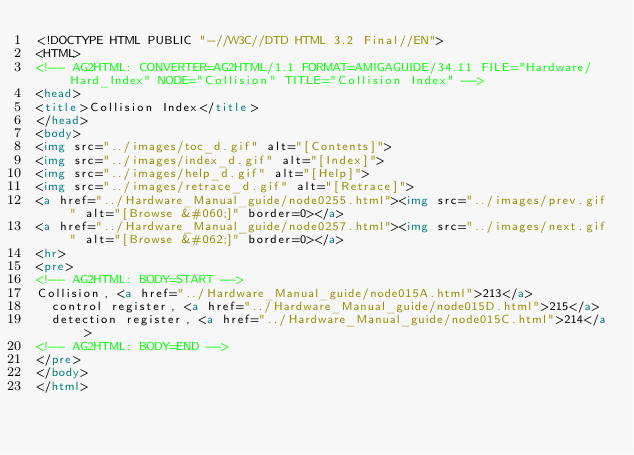<code> <loc_0><loc_0><loc_500><loc_500><_HTML_><!DOCTYPE HTML PUBLIC "-//W3C//DTD HTML 3.2 Final//EN">
<HTML>
<!-- AG2HTML: CONVERTER=AG2HTML/1.1 FORMAT=AMIGAGUIDE/34.11 FILE="Hardware/Hard_Index" NODE="Collision" TITLE="Collision Index" -->
<head>
<title>Collision Index</title>
</head>
<body>
<img src="../images/toc_d.gif" alt="[Contents]">
<img src="../images/index_d.gif" alt="[Index]">
<img src="../images/help_d.gif" alt="[Help]">
<img src="../images/retrace_d.gif" alt="[Retrace]">
<a href="../Hardware_Manual_guide/node0255.html"><img src="../images/prev.gif" alt="[Browse &#060;]" border=0></a>
<a href="../Hardware_Manual_guide/node0257.html"><img src="../images/next.gif" alt="[Browse &#062;]" border=0></a>
<hr>
<pre>
<!-- AG2HTML: BODY=START -->
Collision, <a href="../Hardware_Manual_guide/node015A.html">213</a> 
  control register, <a href="../Hardware_Manual_guide/node015D.html">215</a> 
  detection register, <a href="../Hardware_Manual_guide/node015C.html">214</a> 
<!-- AG2HTML: BODY=END -->
</pre>
</body>
</html>
</code> 